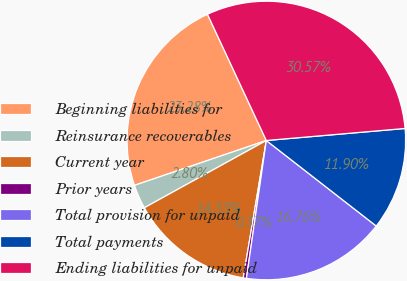<chart> <loc_0><loc_0><loc_500><loc_500><pie_chart><fcel>Beginning liabilities for<fcel>Reinsurance recoverables<fcel>Current year<fcel>Prior years<fcel>Total provision for unpaid<fcel>Total payments<fcel>Ending liabilities for unpaid<nl><fcel>23.28%<fcel>2.8%<fcel>14.33%<fcel>0.37%<fcel>16.76%<fcel>11.9%<fcel>30.57%<nl></chart> 